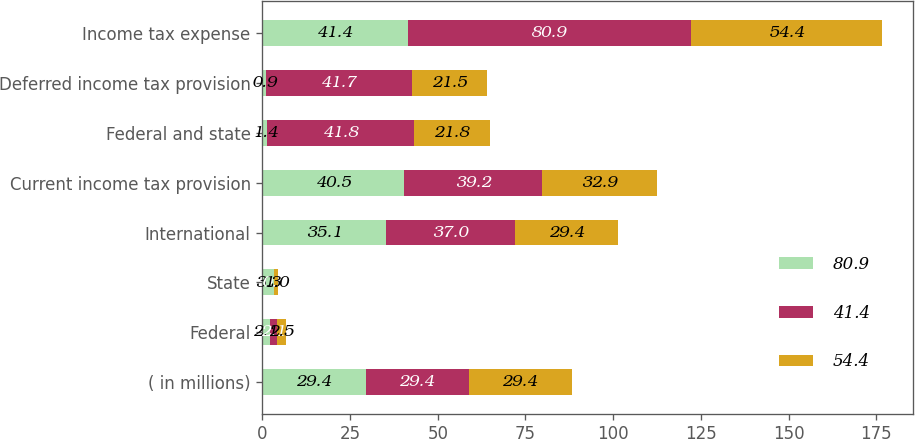Convert chart to OTSL. <chart><loc_0><loc_0><loc_500><loc_500><stacked_bar_chart><ecel><fcel>( in millions)<fcel>Federal<fcel>State<fcel>International<fcel>Current income tax provision<fcel>Federal and state<fcel>Deferred income tax provision<fcel>Income tax expense<nl><fcel>80.9<fcel>29.4<fcel>2.1<fcel>3.3<fcel>35.1<fcel>40.5<fcel>1.4<fcel>0.9<fcel>41.4<nl><fcel>41.4<fcel>29.4<fcel>2.1<fcel>0.1<fcel>37<fcel>39.2<fcel>41.8<fcel>41.7<fcel>80.9<nl><fcel>54.4<fcel>29.4<fcel>2.5<fcel>1<fcel>29.4<fcel>32.9<fcel>21.8<fcel>21.5<fcel>54.4<nl></chart> 